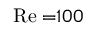<formula> <loc_0><loc_0><loc_500><loc_500>R e = 1 0 0</formula> 